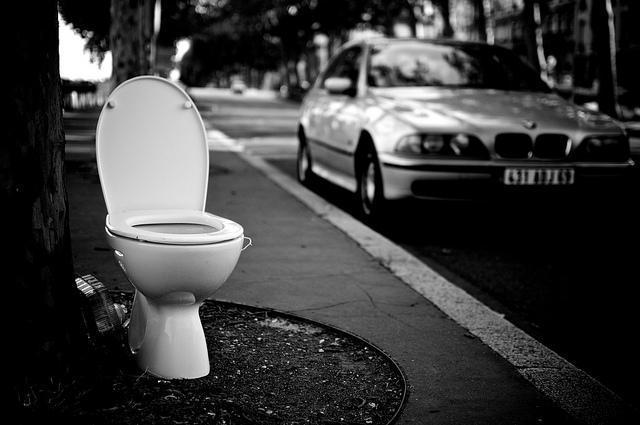How many people have cameras up to their faces?
Give a very brief answer. 0. 